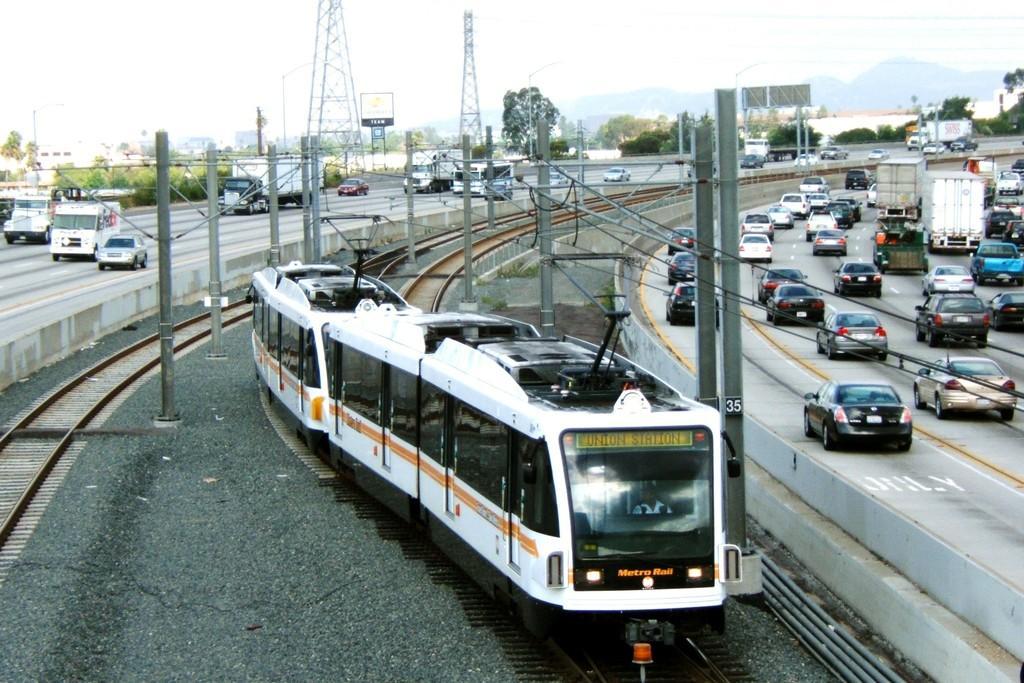Please provide a concise description of this image. In the front of the image I can see train is on the track, vehicles are on the road, poles and things. In the background of the image there are boards, towers, trees, hills and sky. 